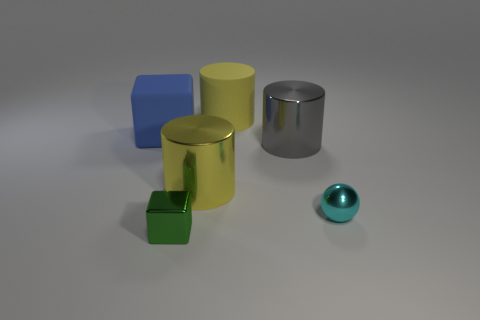How many other things are there of the same shape as the big gray object?
Your answer should be very brief. 2. What number of other objects are there of the same material as the blue thing?
Your answer should be compact. 1. What material is the yellow thing that is in front of the matte object to the right of the matte thing that is to the left of the green shiny block?
Provide a succinct answer. Metal. Do the blue cube and the tiny green block have the same material?
Your answer should be very brief. No. What number of cylinders are tiny green metal objects or cyan things?
Provide a short and direct response. 0. What is the color of the tiny shiny block that is on the left side of the cyan metal object?
Provide a short and direct response. Green. How many metal things are gray cylinders or spheres?
Ensure brevity in your answer.  2. There is a object that is behind the blue thing that is to the left of the large matte cylinder; what is it made of?
Provide a succinct answer. Rubber. There is another big cylinder that is the same color as the large matte cylinder; what material is it?
Ensure brevity in your answer.  Metal. What is the color of the tiny shiny sphere?
Your response must be concise. Cyan. 